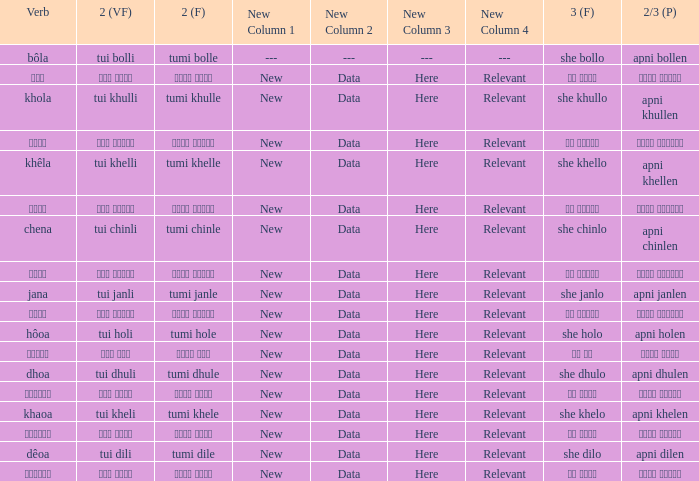What is the 2(vf) for তুমি বললে? তুই বললি. 